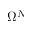Convert formula to latex. <formula><loc_0><loc_0><loc_500><loc_500>\Omega ^ { N }</formula> 